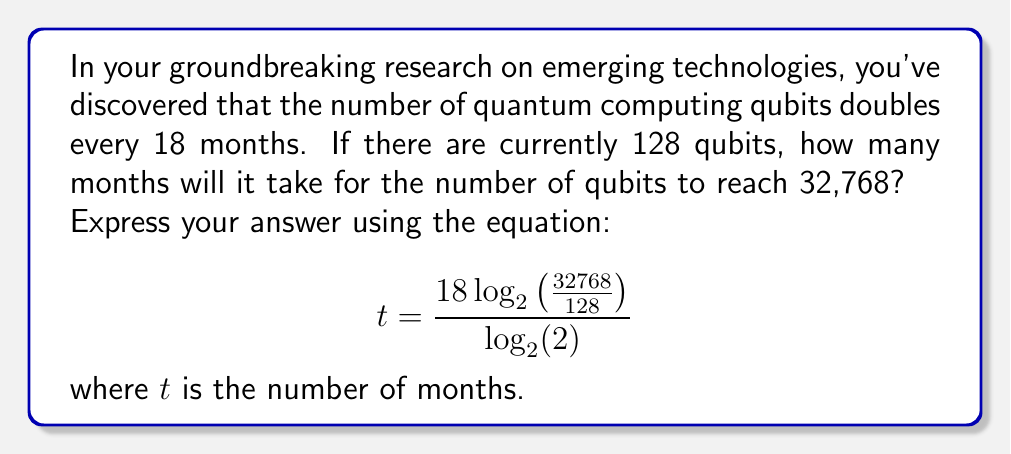Solve this math problem. Let's approach this step-by-step:

1) First, we need to understand the exponential growth model:
   $N = N_0 \cdot 2^{\frac{t}{18}}$
   where $N$ is the final number of qubits, $N_0$ is the initial number of qubits, and $t$ is the time in months.

2) We have:
   $N_0 = 128$ (initial qubits)
   $N = 32768$ (final qubits)

3) Substituting these into our equation:
   $32768 = 128 \cdot 2^{\frac{t}{18}}$

4) Dividing both sides by 128:
   $\frac{32768}{128} = 2^{\frac{t}{18}}$

5) Taking $\log_2$ of both sides:
   $\log_2(\frac{32768}{128}) = \log_2(2^{\frac{t}{18}})$

6) Using the logarithm property $\log_a(a^x) = x$:
   $\log_2(\frac{32768}{128}) = \frac{t}{18}$

7) Multiplying both sides by 18:
   $18 \log_2(\frac{32768}{128}) = t$

8) This gives us our final equation:
   $t = \frac{18 \log_2(\frac{32768}{128})}{\log_2(2)}$

9) Simplifying inside the logarithm:
   $\frac{32768}{128} = 256$

10) Therefore:
    $t = \frac{18 \log_2(256)}{\log_2(2)} = \frac{18 \cdot 8}{1} = 144$

Thus, it will take 144 months for the number of qubits to reach 32,768.
Answer: 144 months 